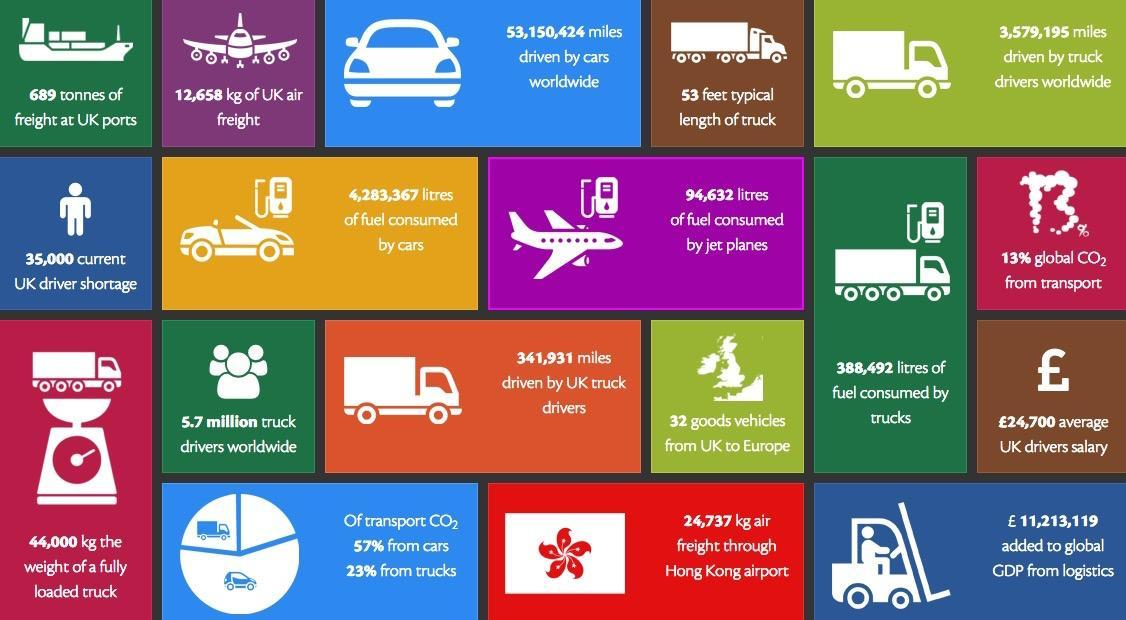How many images of planes are given in this infographic?
Answer the question with a short phrase. 2 Fuel consumption by which one is higher - cars, trucks or jet planes? cars What is the difference in percentage of CO2 emission by cars and trucks? 34% Fuel consumption by which one is higher - cars or jet planes? cars What is the difference(in liters) between fuel consumed by cars and jet planes? 4188735 What percentage of total miles driven by truck drivers worldwide is driven by UK truck drivers? 9.5 Fuel consumption by which one is higher - cars or trucks? cars How many images of trucks are given in this infographic? 5 What is the difference(in liters) between fuel consumed by cars and trucks? 3894875 CO2 emission from which vehicle is higher - cars or trucks? cars 